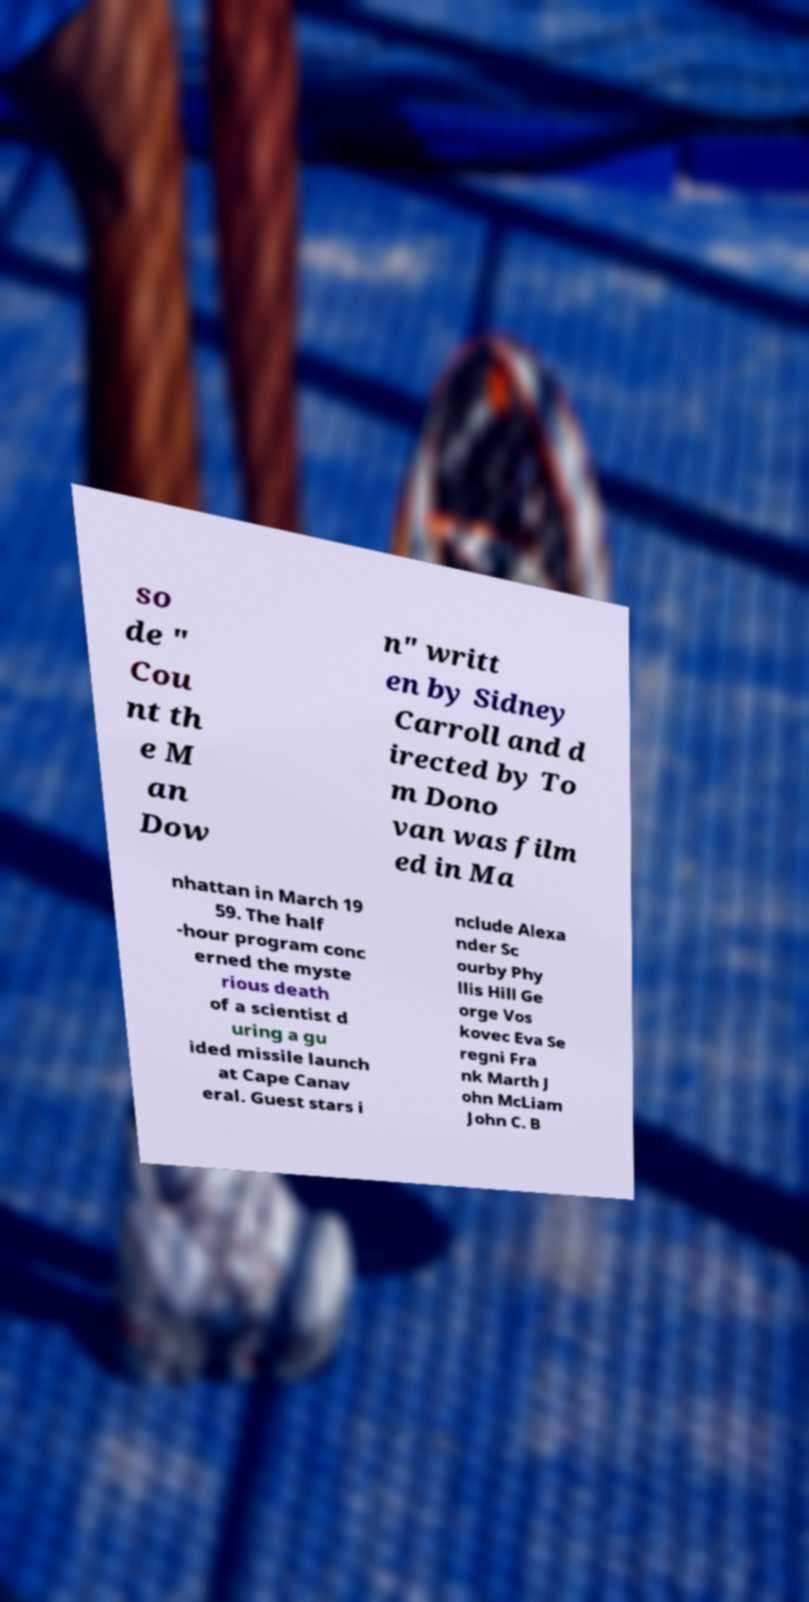Please read and relay the text visible in this image. What does it say? so de " Cou nt th e M an Dow n" writt en by Sidney Carroll and d irected by To m Dono van was film ed in Ma nhattan in March 19 59. The half -hour program conc erned the myste rious death of a scientist d uring a gu ided missile launch at Cape Canav eral. Guest stars i nclude Alexa nder Sc ourby Phy llis Hill Ge orge Vos kovec Eva Se regni Fra nk Marth J ohn McLiam John C. B 